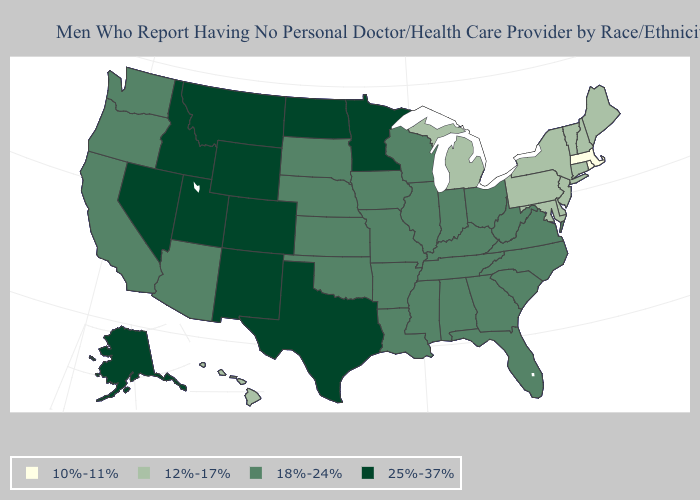What is the value of South Carolina?
Answer briefly. 18%-24%. What is the lowest value in the South?
Short answer required. 12%-17%. What is the highest value in the West ?
Concise answer only. 25%-37%. What is the value of California?
Short answer required. 18%-24%. Name the states that have a value in the range 18%-24%?
Be succinct. Alabama, Arizona, Arkansas, California, Florida, Georgia, Illinois, Indiana, Iowa, Kansas, Kentucky, Louisiana, Mississippi, Missouri, Nebraska, North Carolina, Ohio, Oklahoma, Oregon, South Carolina, South Dakota, Tennessee, Virginia, Washington, West Virginia, Wisconsin. Among the states that border Massachusetts , does Rhode Island have the highest value?
Concise answer only. No. Does the first symbol in the legend represent the smallest category?
Answer briefly. Yes. Does Arizona have the highest value in the West?
Give a very brief answer. No. What is the lowest value in states that border Alabama?
Short answer required. 18%-24%. Name the states that have a value in the range 10%-11%?
Give a very brief answer. Massachusetts, Rhode Island. What is the value of Utah?
Be succinct. 25%-37%. Does New York have a lower value than Hawaii?
Short answer required. No. What is the value of Virginia?
Answer briefly. 18%-24%. What is the highest value in states that border Iowa?
Quick response, please. 25%-37%. What is the lowest value in the West?
Concise answer only. 12%-17%. 